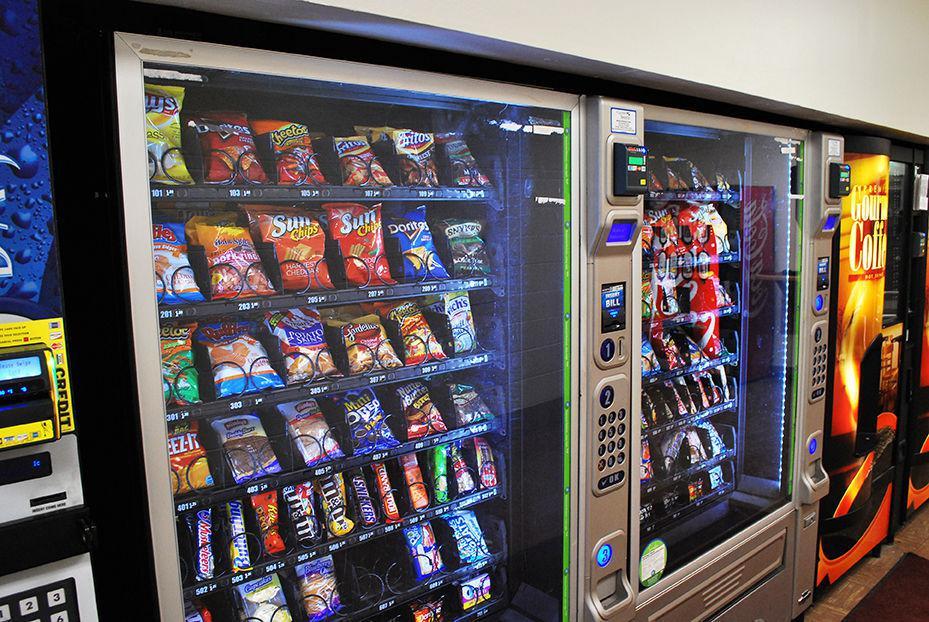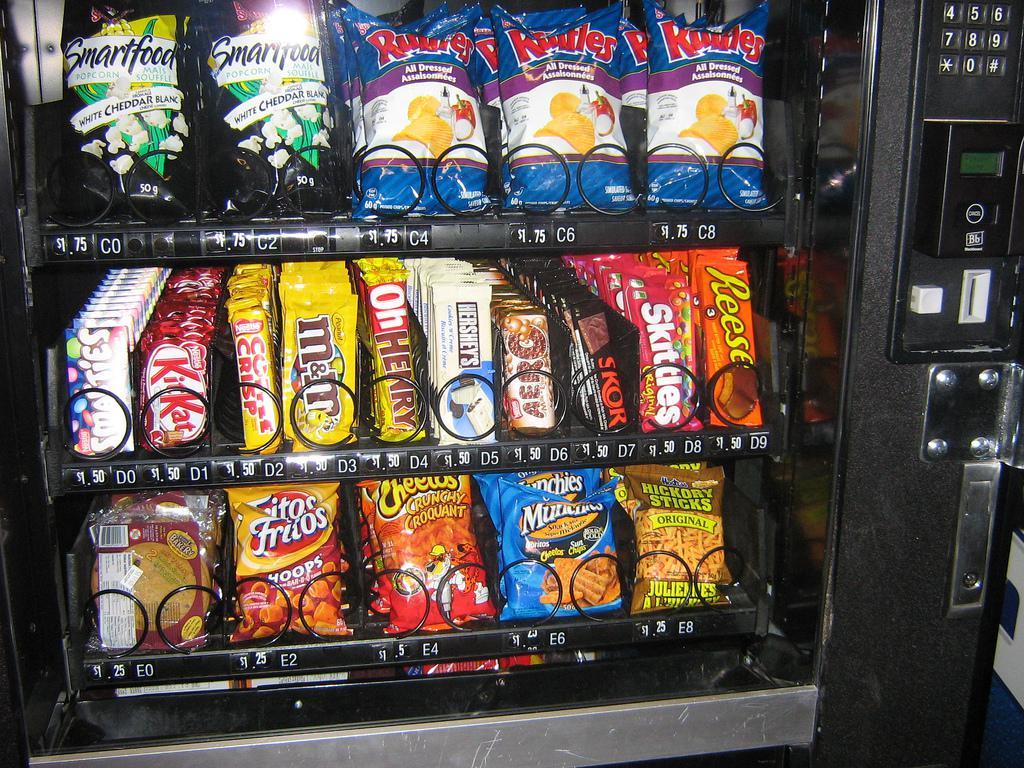The first image is the image on the left, the second image is the image on the right. For the images shown, is this caption "There are items falling from their shelves in both images." true? Answer yes or no. No. The first image is the image on the left, the second image is the image on the right. Analyze the images presented: Is the assertion "At least one of the images shows snacks that have got stuck in a vending machine." valid? Answer yes or no. No. 